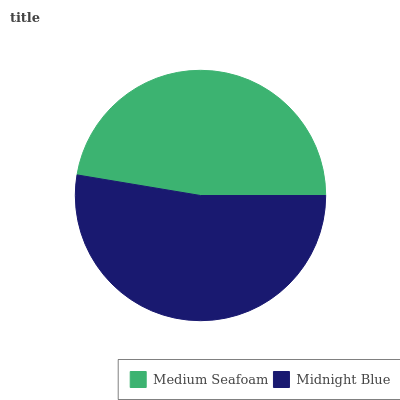Is Medium Seafoam the minimum?
Answer yes or no. Yes. Is Midnight Blue the maximum?
Answer yes or no. Yes. Is Midnight Blue the minimum?
Answer yes or no. No. Is Midnight Blue greater than Medium Seafoam?
Answer yes or no. Yes. Is Medium Seafoam less than Midnight Blue?
Answer yes or no. Yes. Is Medium Seafoam greater than Midnight Blue?
Answer yes or no. No. Is Midnight Blue less than Medium Seafoam?
Answer yes or no. No. Is Midnight Blue the high median?
Answer yes or no. Yes. Is Medium Seafoam the low median?
Answer yes or no. Yes. Is Medium Seafoam the high median?
Answer yes or no. No. Is Midnight Blue the low median?
Answer yes or no. No. 